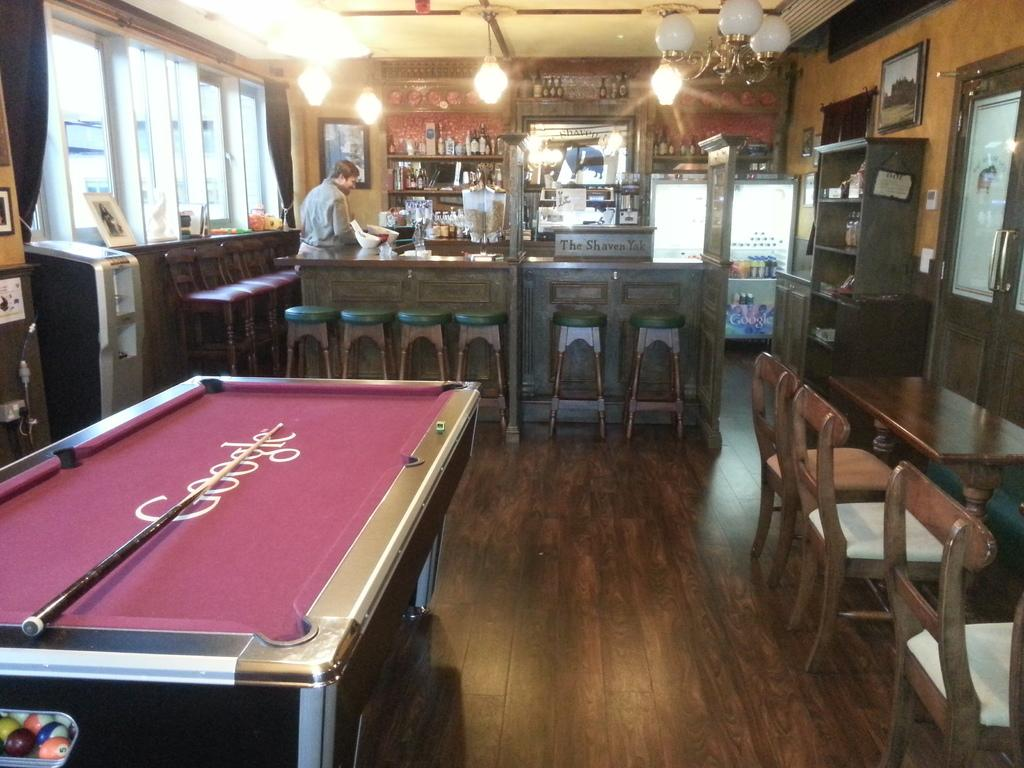What can be seen in the image that provides illumination? There are lights in the image. What architectural feature is present in the image that allows for a view of the outside? There is a window in the image. What type of furniture is visible in the image that people might sit on? There are chairs in the image. What type of furniture is visible in the image that people might use for eating or working? There are tables in the image. Who is present in the image? There is a man standing in the image. What type of chain is the man holding in the image? There is no chain present in the image; the man is simply standing. What type of tooth is visible in the image? There are no teeth visible in the image, as it features a man standing and various furniture and lighting elements. 